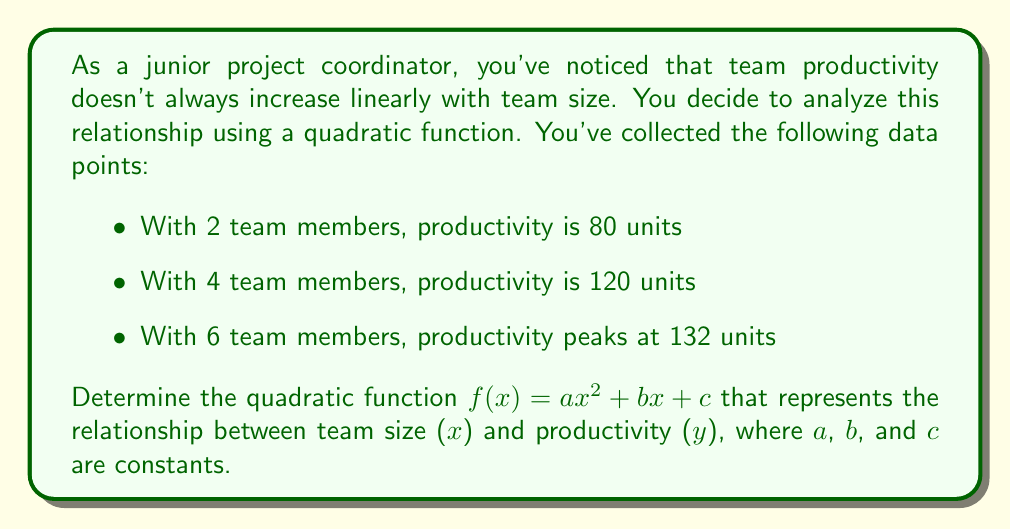Show me your answer to this math problem. To find the quadratic function, we'll use the given data points to create a system of equations and solve for a, b, and c.

1) First, let's set up our three equations using the given data points:

   $4a + 2b + c = 80$  (for x = 2)
   $16a + 4b + c = 120$  (for x = 4)
   $36a + 6b + c = 132$  (for x = 6)

2) Subtract the first equation from the second:
   $12a + 2b = 40$
   $6a + b = 20$  (Equation A)

3) Subtract the second equation from the third:
   $20a + 2b = 12$
   $10a + b = 6$  (Equation B)

4) Subtract Equation B from Equation A:
   $-4a = 14$
   $a = -3.5$

5) Substitute this value of a into Equation A:
   $6(-3.5) + b = 20$
   $-21 + b = 20$
   $b = 41$

6) Now substitute the values of a and b into any of the original equations, let's use the first one:
   $4(-3.5) + 2(41) + c = 80$
   $-14 + 82 + c = 80$
   $c = 12$

Therefore, the quadratic function is:
$f(x) = -3.5x^2 + 41x + 12$
Answer: $f(x) = -3.5x^2 + 41x + 12$ 